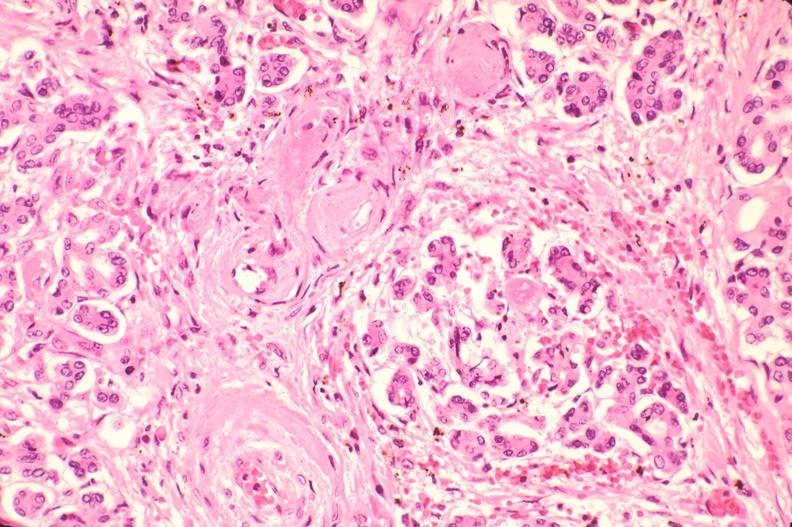what is present?
Answer the question using a single word or phrase. Endocrine 